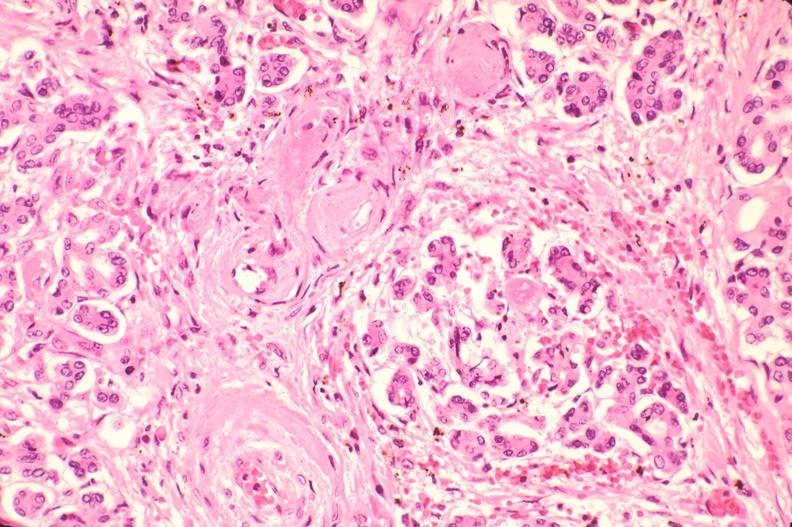what is present?
Answer the question using a single word or phrase. Endocrine 